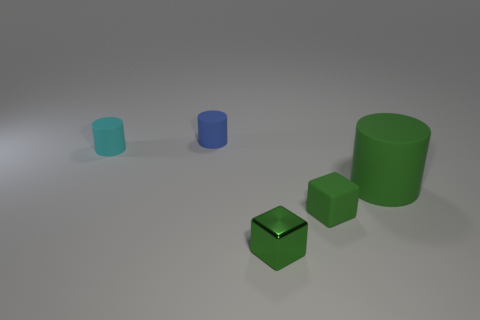Add 3 big brown rubber cylinders. How many objects exist? 8 Subtract all cylinders. How many objects are left? 2 Add 2 green shiny objects. How many green shiny objects are left? 3 Add 4 small gray metallic balls. How many small gray metallic balls exist? 4 Subtract 0 yellow spheres. How many objects are left? 5 Subtract all tiny matte objects. Subtract all gray balls. How many objects are left? 2 